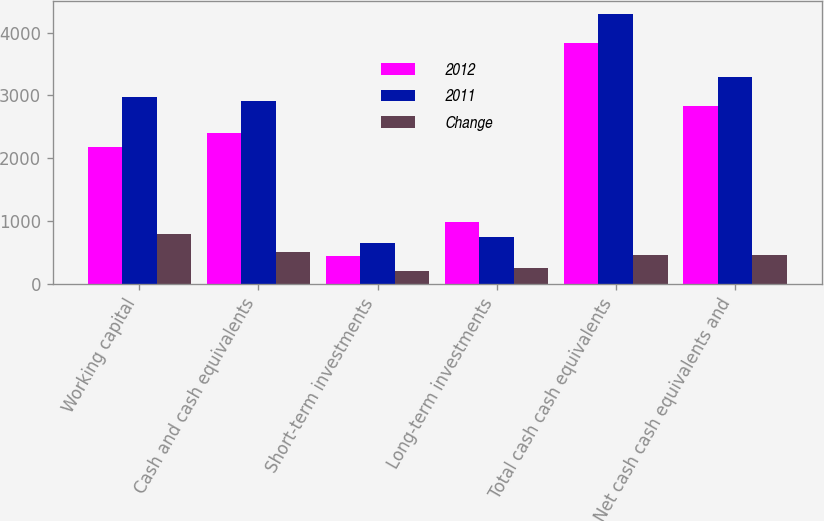<chart> <loc_0><loc_0><loc_500><loc_500><stacked_bar_chart><ecel><fcel>Working capital<fcel>Cash and cash equivalents<fcel>Short-term investments<fcel>Long-term investments<fcel>Total cash cash equivalents<fcel>Net cash cash equivalents and<nl><fcel>2012<fcel>2178.7<fcel>2407.8<fcel>441.5<fcel>988.1<fcel>3837.4<fcel>2838.2<nl><fcel>2011<fcel>2973<fcel>2910.4<fcel>641.3<fcel>740.7<fcel>4292.4<fcel>3293.4<nl><fcel>Change<fcel>794.3<fcel>502.6<fcel>199.8<fcel>247.4<fcel>455<fcel>455.2<nl></chart> 